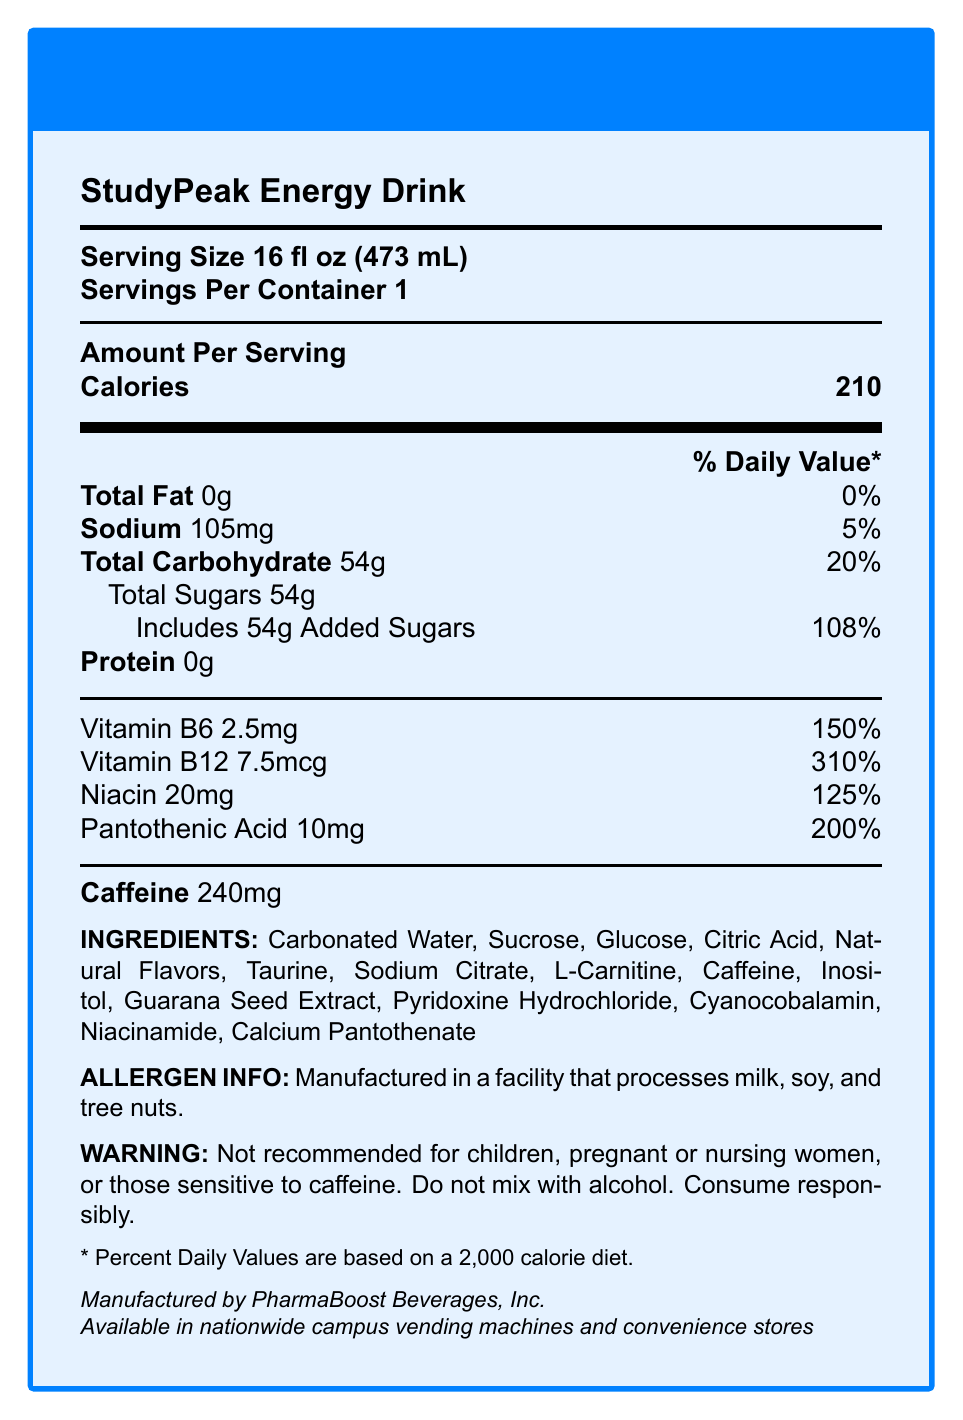what is the serving size of StudyPeak Energy Drink? The serving size is clearly mentioned as "16 fl oz (473 mL)" at the top of the document.
Answer: 16 fl oz (473 mL) how many calories are there per serving? The document lists "Calories 210" under the "Amount Per Serving" section.
Answer: 210 what is the total carbohydrate content? The document lists "Total Carbohydrate" as 54g under the nutritional breakdown.
Answer: 54g what percentage of the daily value does the sodium content represent? The document lists "Sodium" as 105mg, representing 5% of the daily value.
Answer: 5% which vitamin has the highest percent daily value? The document shows "Vitamin B12 7.5mcg" with a daily value percentage of 310%, which is the highest among the listed vitamins.
Answer: Vitamin B12 how much caffeine is in one serving of StudyPeak Energy Drink? The document explicitly states "Caffeine 240mg".
Answer: 240mg what ingredients are listed under the "ingredients" section? The document lists all these ingredients under the "INGREDIENTS" section.
Answer: Carbonated Water, Sucrose, Glucose, Citric Acid, Natural Flavors, Taurine, Sodium Citrate, L-Carnitine, Caffeine, Inositol, Guarana Seed Extract, Pyridoxine Hydrochloride, Cyanocobalamin, Niacinamide, Calcium Pantothenate how many servings are in one container? The document states that there is 1 serving per container.
Answer: 1 what is the allergen information provided for StudyPeak Energy Drink? The allergen information is clearly mentioned in the document.
Answer: Manufactured in a facility that processes milk, soy, and tree nuts. which of the following vitamins is NOT listed in the document? A. Vitamin B6 B. Vitamin D C. Niacin D. Pantothenic Acid The document lists Vitamin B6, Niacin, and Pantothenic Acid, but does not mention Vitamin D.
Answer: B. Vitamin D what is the percentage of daily value for added sugars? The document lists "Includes 54g Added Sugars - 108%" under the Total Carbohydrate section.
Answer: 108% who manufactures StudyPeak Energy Drink? A. PharmaBoost Beverages, Inc. B. HealthPeak Inc. C. EnergyMax Co. The document states "Manufactured by PharmaBoost Beverages, Inc."
Answer: A. PharmaBoost Beverages, Inc. is StudyPeak Energy Drink safe for children? The document has a warning stating it's not recommended for children.
Answer: No summarize the main idea of the document. The main idea is to give comprehensive nutrition and safety details of the StudyPeak Energy Drink to inform consumers about its contents and any related health advisories.
Answer: The document provides detailed nutritional information for StudyPeak Energy Drink, including serving size, calories, macro- and micronutrient content, ingredients, allergen information, and safety warnings. can the exact expiration date of StudyPeak Energy Drink be found in the document? The document does not mention anything about the expiration date, so it cannot be determined from the provided information.
Answer: Not enough information 